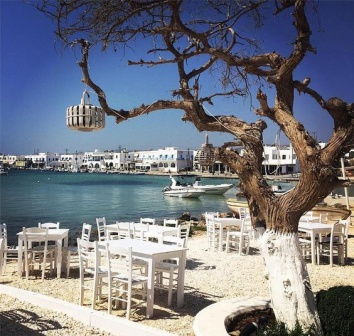Can you describe the main features of this image for me? The image portrays a serene seaside restaurant setting on a sunny day. The restaurant patio consists of white tables and chairs arranged neatly on a stone surface, inviting guests to dine outdoors. A prominent tree stands in the foreground, with its bare branches adorned by a rustic birdcage hanging from one of them, adding a charming touch to the atmosphere. In the background, the view reveals a tranquil harbor lined with white buildings whose reflections play on the shimmering light turquoise water. Several boats of different sizes are docked at the harbor, signifying leisurely activities or fishing ventures. The sky above is a clear, vibrant blue, enhancing the cheerful vibe of the scene. Overall, the image exudes a sense of relaxation, picturesque beauty, and an inviting ambiance for enjoying a meal by the sea. 